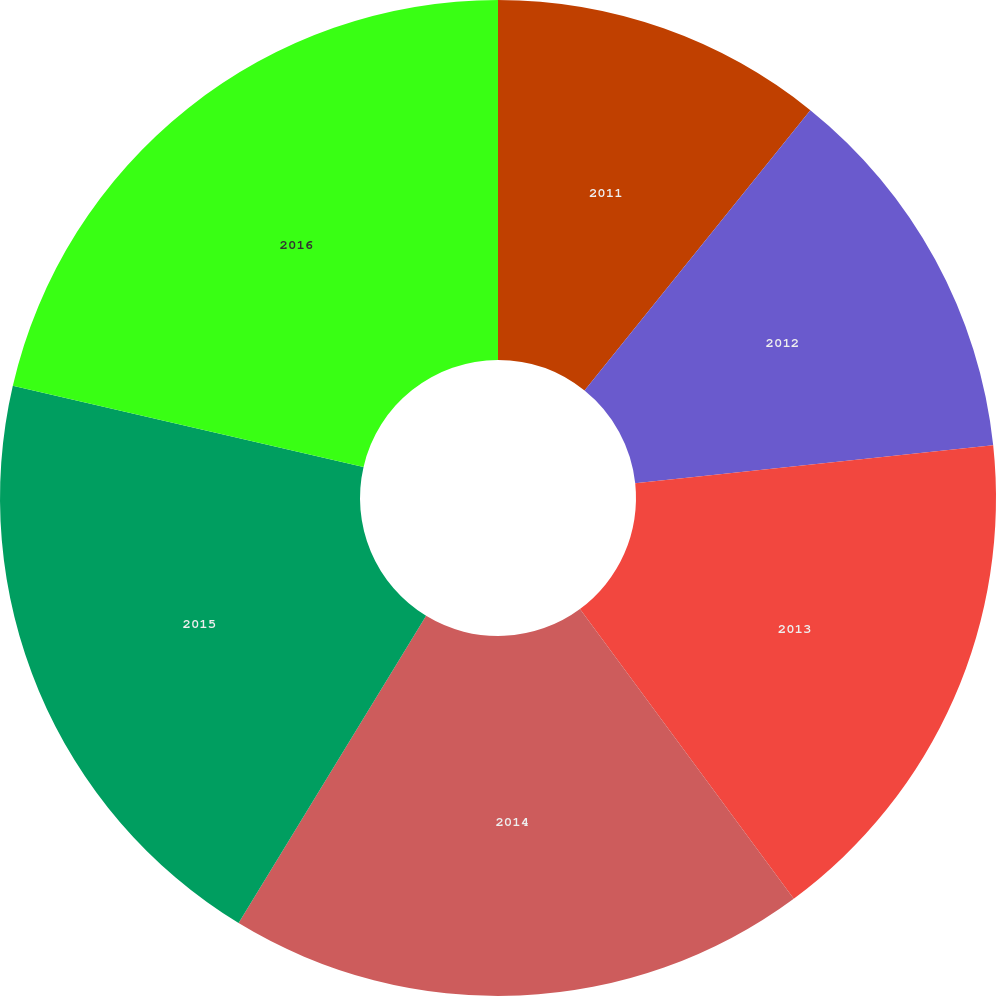<chart> <loc_0><loc_0><loc_500><loc_500><pie_chart><fcel>2011<fcel>2012<fcel>2013<fcel>2014<fcel>2015<fcel>2016<nl><fcel>10.79%<fcel>12.52%<fcel>16.57%<fcel>18.84%<fcel>19.9%<fcel>21.38%<nl></chart> 